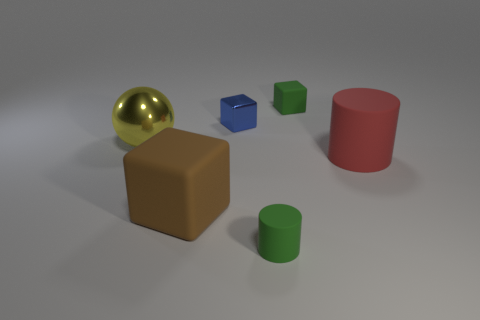Add 4 tiny blue objects. How many objects exist? 10 Subtract all cylinders. How many objects are left? 4 Add 1 tiny green cylinders. How many tiny green cylinders are left? 2 Add 5 small rubber objects. How many small rubber objects exist? 7 Subtract 0 green balls. How many objects are left? 6 Subtract all tiny green matte cylinders. Subtract all tiny yellow shiny blocks. How many objects are left? 5 